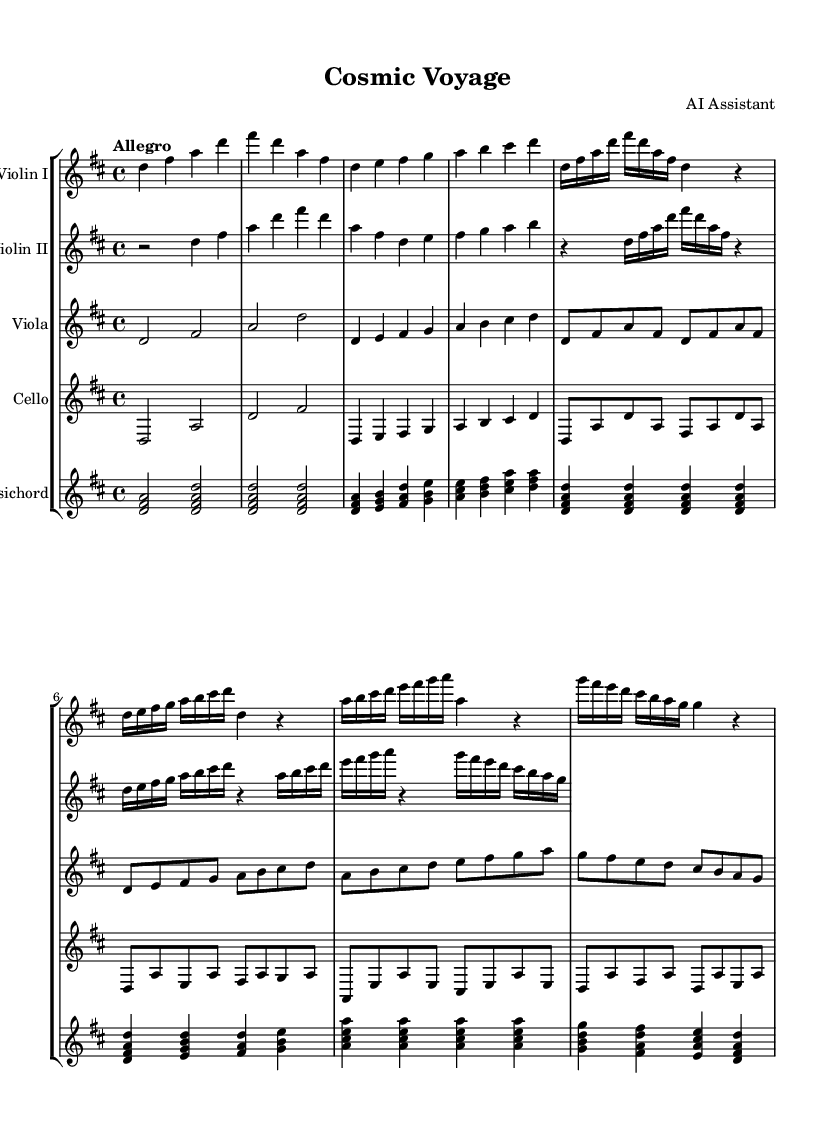What is the key signature of this music? The key signature shown at the beginning indicates D major, which has two sharps (F# and C#).
Answer: D major What is the time signature used in this piece? The time signature is displayed at the beginning of the score, indicating a 4/4 time signature, meaning there are four beats in a measure.
Answer: 4/4 What is the tempo marking of this composition? The tempo marking at the beginning specifies "Allegro," which suggests a fast and lively pace for the piece.
Answer: Allegro How many sections are there in the music? By analyzing the structure, the piece has two main themes (Theme A and Theme B), indicating it has at least two distinct sections.
Answer: Two Which instruments are featured in this chamber music? The score lists five instruments: Violin I, Violin II, Viola, Cello, and Harpsichord, showing that it is a string ensemble supported by a keyboard.
Answer: Violin I, Violin II, Viola, Cello, Harpsichord What type of harmony is primarily used in this piece? The presence of chords involving multiple instruments, particularly the harpsichord using triads, indicates it employs a harmonic texture typical of Baroque music.
Answer: Triadic harmony How does the music convey excitement and anticipation? The choice of fast tempo (Allegro), along with the rhythmic drive and ascending melodic lines, creates a sense of energy and forward motion, reflecting excitement about space travel.
Answer: Fast tempo and ascending lines 